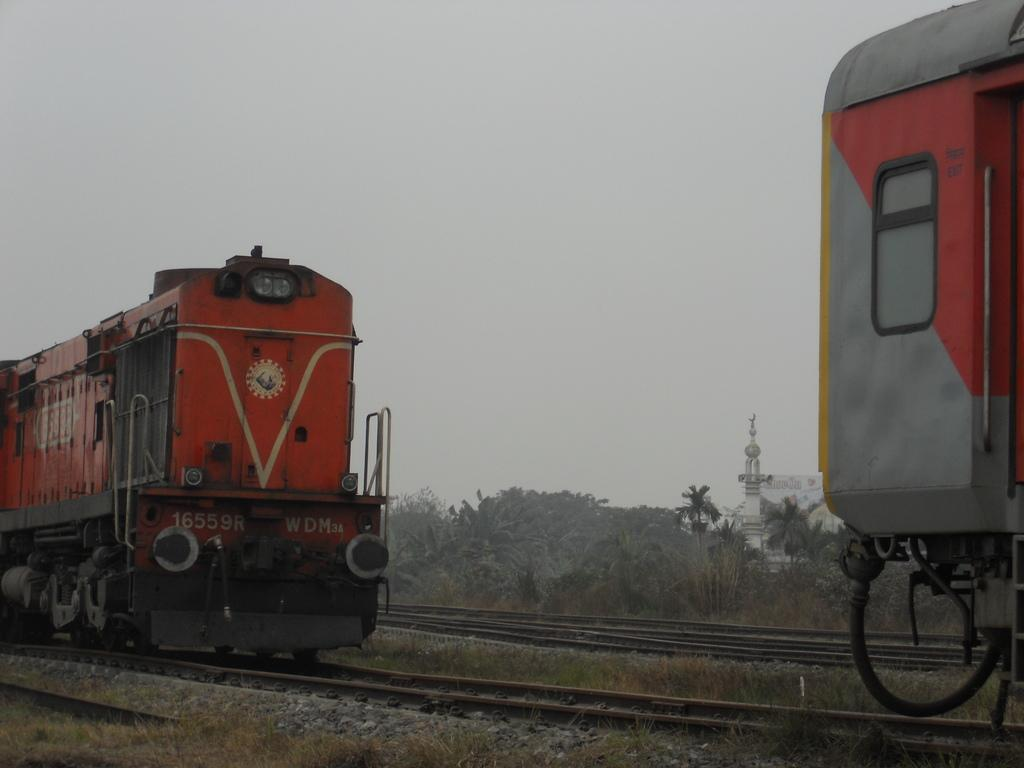What is the main subject of the image? The main subject of the image is trains on the track. What type of terrain can be seen in the image? There are stones and grass visible in the image. What type of vegetation is present in the image? There is a group of trees in the image. What structure can be seen in the image? There is a tower in the image. What is the condition of the sky in the image? The sky is visible in the image and appears cloudy. What type of basket is being used to carry the system in the image? There is no basket or system present in the image; it features trains on a track with a cloudy sky, stones, grass, trees, and a tower. 